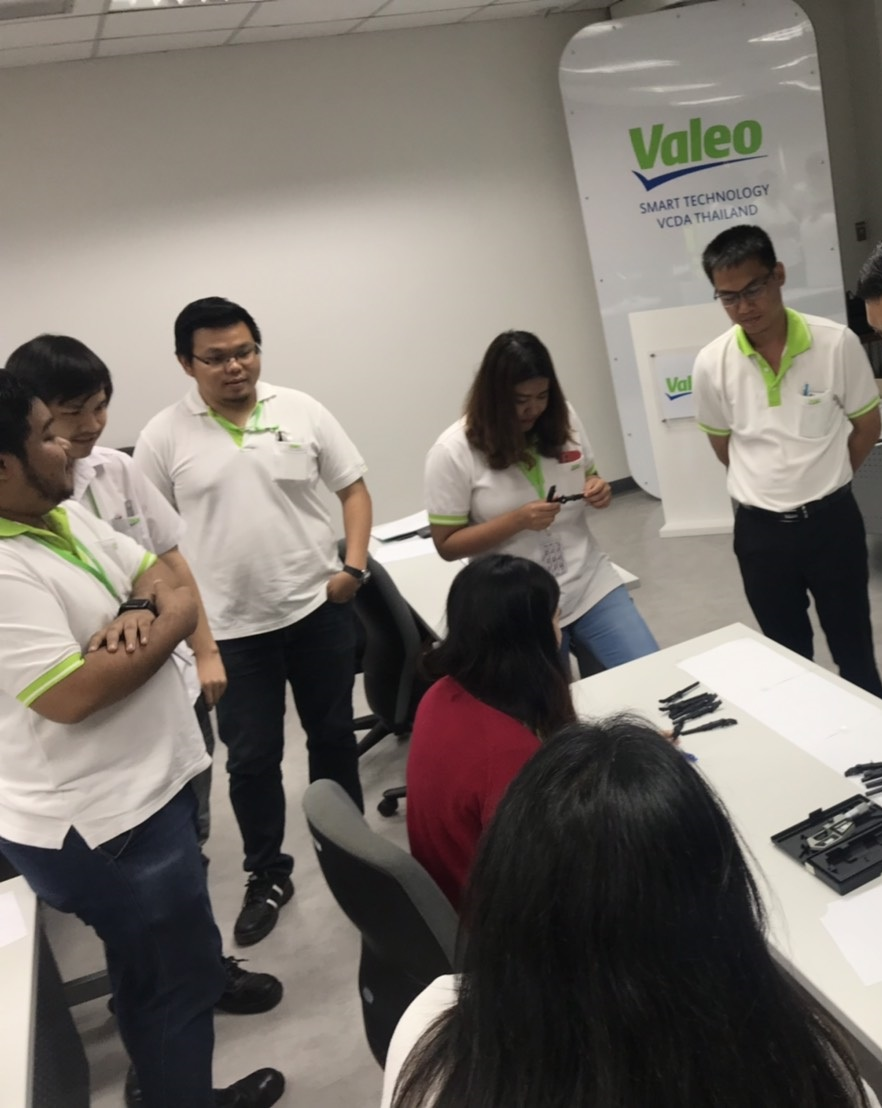What might be the topic or nature of the discussion based on the objects and environment seen around the group? Based on the objects and environment seen around the group, it can be inferred that the discussion might be related to a corporate or team activity focused on the company's interests or projects. The presence of a promotional stand with “Valeo” and “SMART TECHNOLOGY” suggests that the topic could be related to technology or innovation. The casual yet uniform attire of the individuals, with logos on the shirts, implies a company-sponsored event or an internal collaborative activity. The table with papers and pens indicates that the meeting is interactive, possibly involving brainstorming or workshopping ideas. The environment does not appear formal, suggesting a more collaborative and possibly educational or developmental session, such as a team-building exercise or a project planning meeting. 